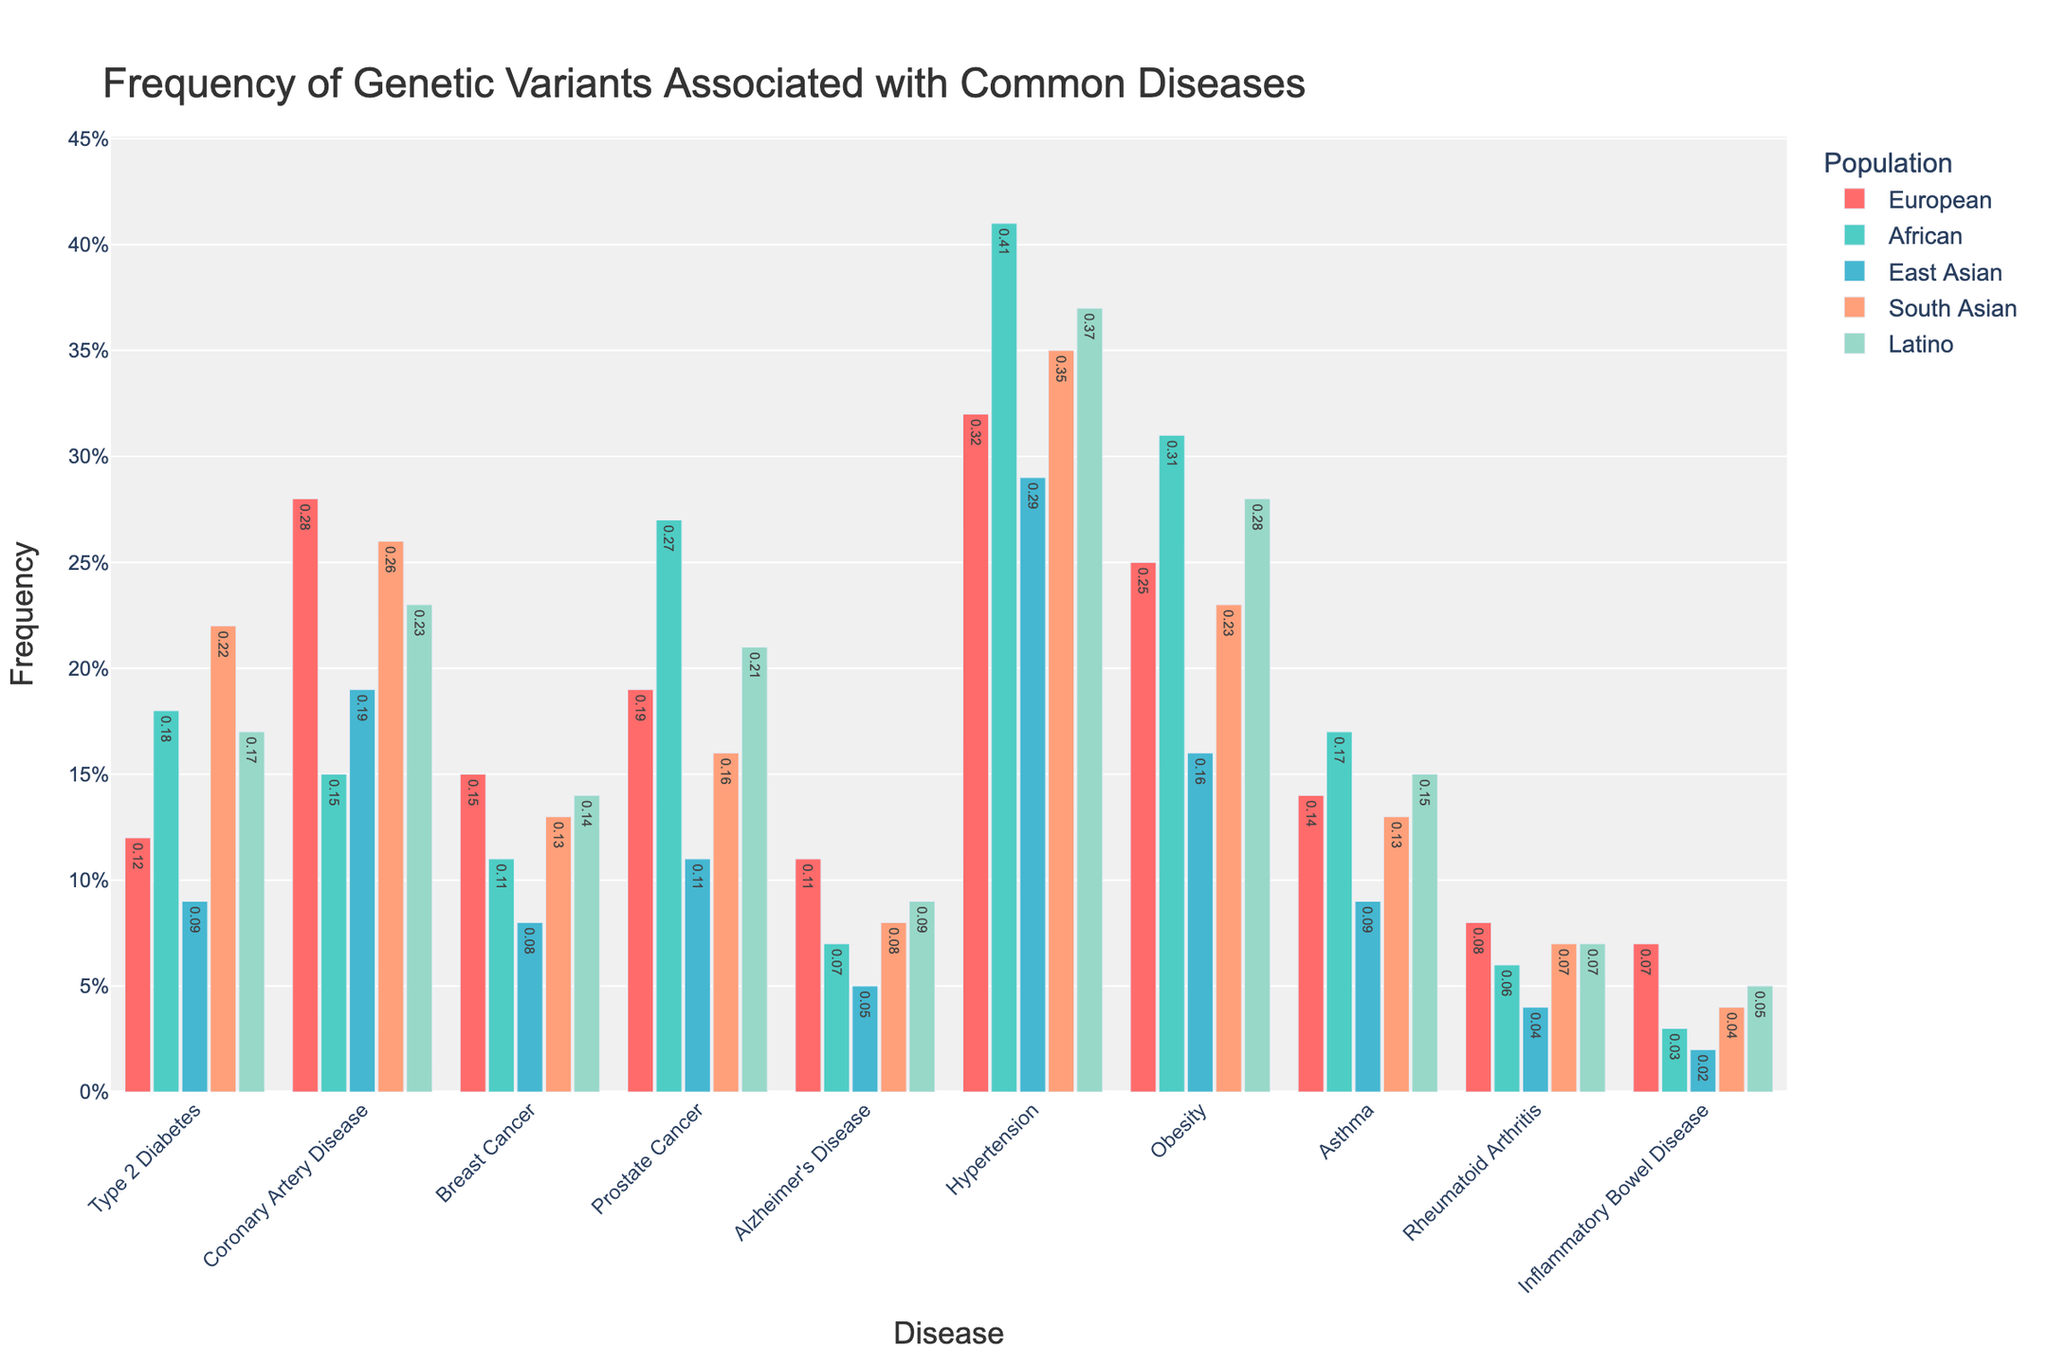Which population has the highest frequency of genetic variants for Type 2 Diabetes? Look at the bars corresponding to Type 2 Diabetes. The bar for South Asian is the tallest.
Answer: South Asian Which disease has the least frequency of genetic variants in East Asian populations? Look at the bars for East Asian. The smallest bar represents Inflammatory Bowel Disease.
Answer: Inflammatory Bowel Disease What is the average frequency of genetic variants for Hypertension across all populations? Sum the frequencies for Hypertension across all populations (0.32 + 0.41 + 0.29 + 0.35 + 0.37) and divide by the number of populations (5). (0.32 + 0.41 + 0.29 + 0.35 + 0.37) / 5 = 1.74 / 5 = 0.348
Answer: 0.348 Compare the frequencies of genetic variants for Coronary Artery Disease in European and Latino populations. Which is higher? Look at the bars for Coronary Artery Disease in both populations. The bar for European is taller than the one for Latino.
Answer: European What is the difference in frequency of genetic variants for Prostate Cancer between African and East Asian populations? Subtract the frequency for East Asian (0.11) from the frequency for African (0.27). 0.27 - 0.11 = 0.16
Answer: 0.16 Among all populations, which disease has the highest frequency of genetic variants? Look at all bars for all diseases. The tallest bar corresponds to Hypertension in African populations.
Answer: Hypertension in African What is the total frequency of genetic variants for Breast Cancer across European and African populations? Sum the frequencies for Breast Cancer in European and African populations (0.15 + 0.11). 0.15 + 0.11 = 0.26
Answer: 0.26 Which disease shows the most significant variation in frequency of genetic variants across different populations? By comparing the heights of the bars for each disease, Hypertension shows the most considerable variation in frequencies.
Answer: Hypertension Is the frequency of genetic variants for Alzheimer's Disease in South Asian populations higher or lower than in European populations? Compare the bars for Alzheimer's Disease in South Asian (0.08) and European populations (0.11). The bar for South Asian is shorter.
Answer: Lower 